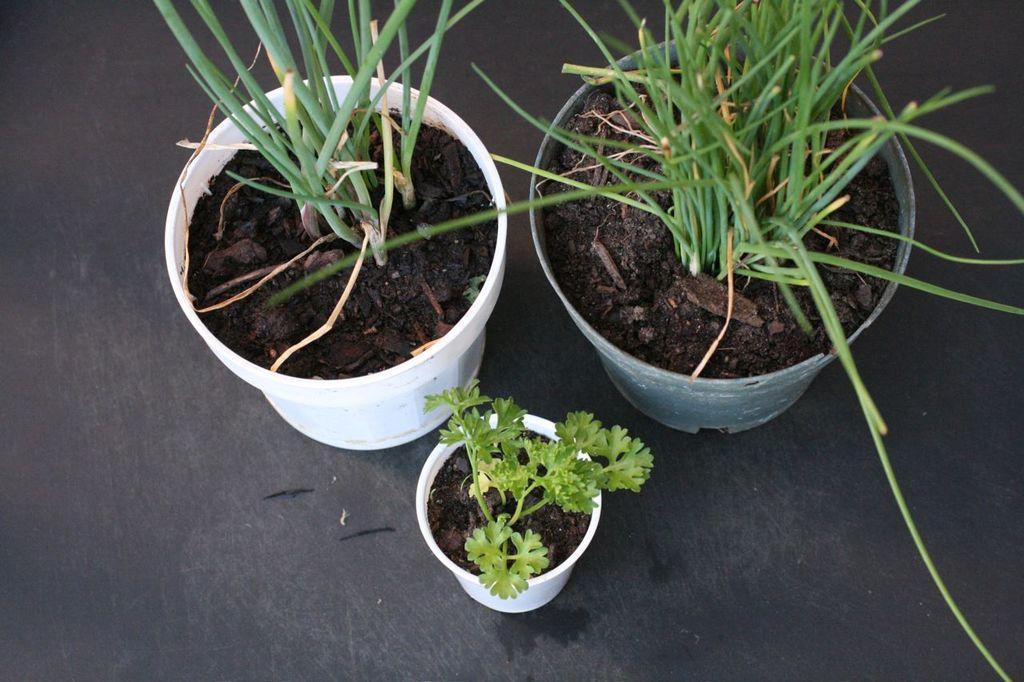Describe this image in one or two sentences. In this image we can see three pots with mud and plants on the floor. There are few small objects near the pots on the floor. 